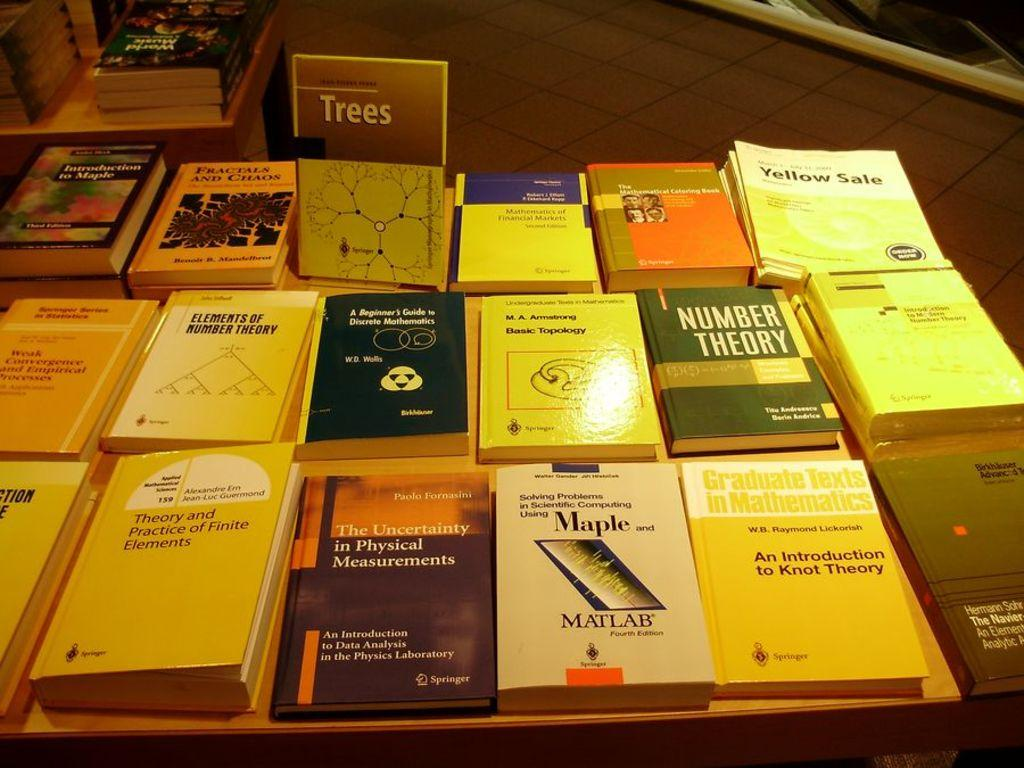<image>
Share a concise interpretation of the image provided. A variety of books on a table which titles include Number Theory, Yellow Sale and others. 